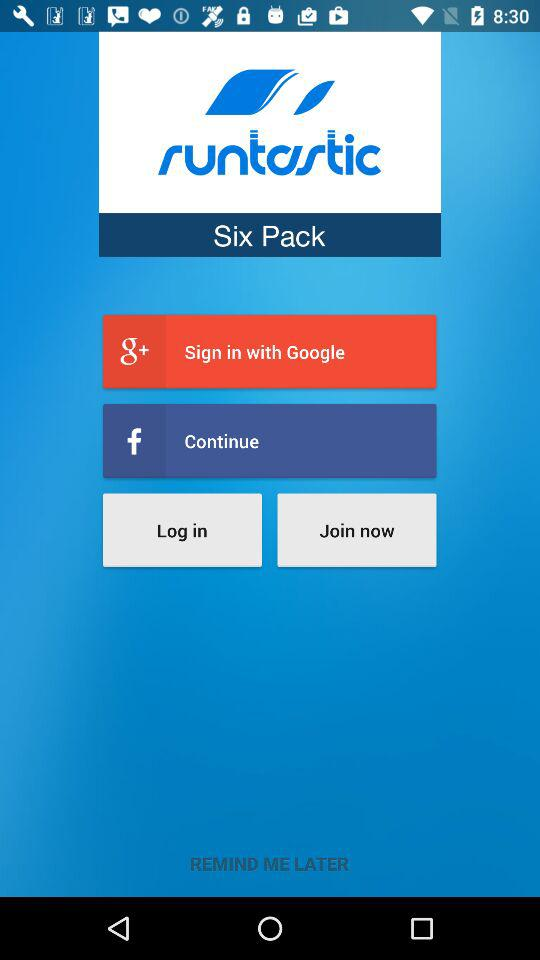With which account can the user continue? The user can continue with "Google+" and "Facebook". 